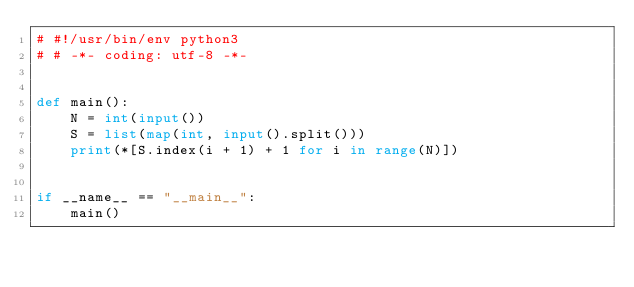Convert code to text. <code><loc_0><loc_0><loc_500><loc_500><_Python_># #!/usr/bin/env python3
# # -*- coding: utf-8 -*-


def main():
    N = int(input())
    S = list(map(int, input().split()))
    print(*[S.index(i + 1) + 1 for i in range(N)])


if __name__ == "__main__":
    main()
</code> 